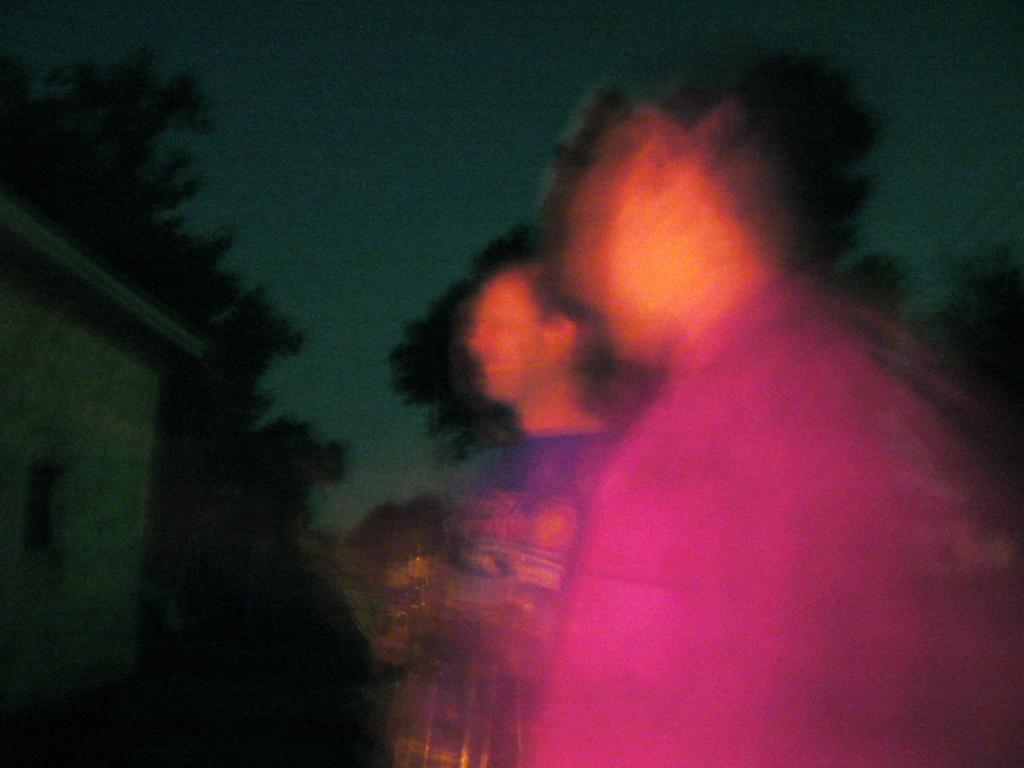How would you summarize this image in a sentence or two? Here we can see the image is blur but we can see two persons, wall, trees and sky. 